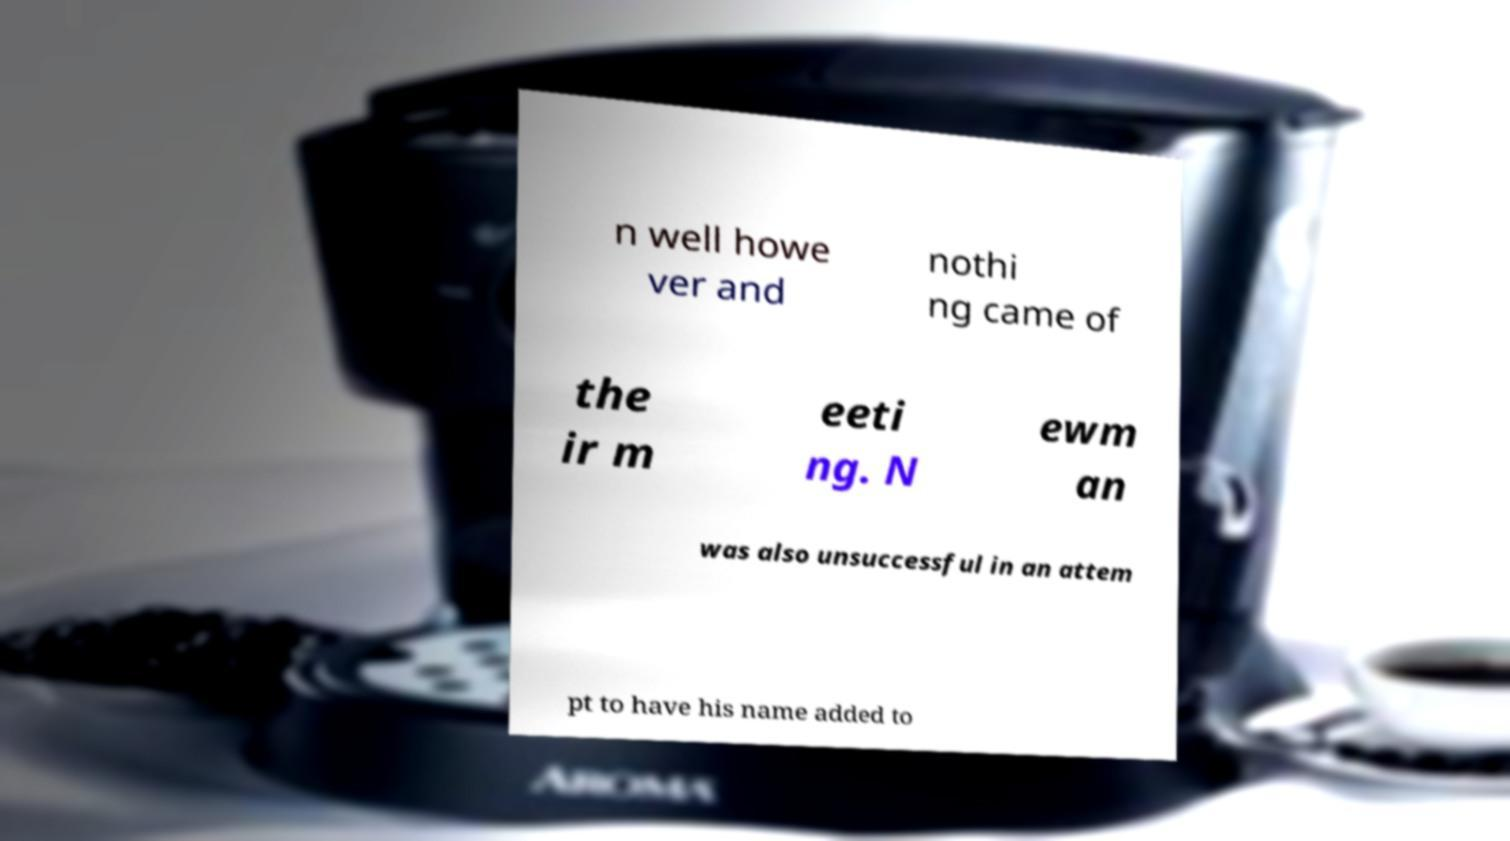Can you accurately transcribe the text from the provided image for me? n well howe ver and nothi ng came of the ir m eeti ng. N ewm an was also unsuccessful in an attem pt to have his name added to 